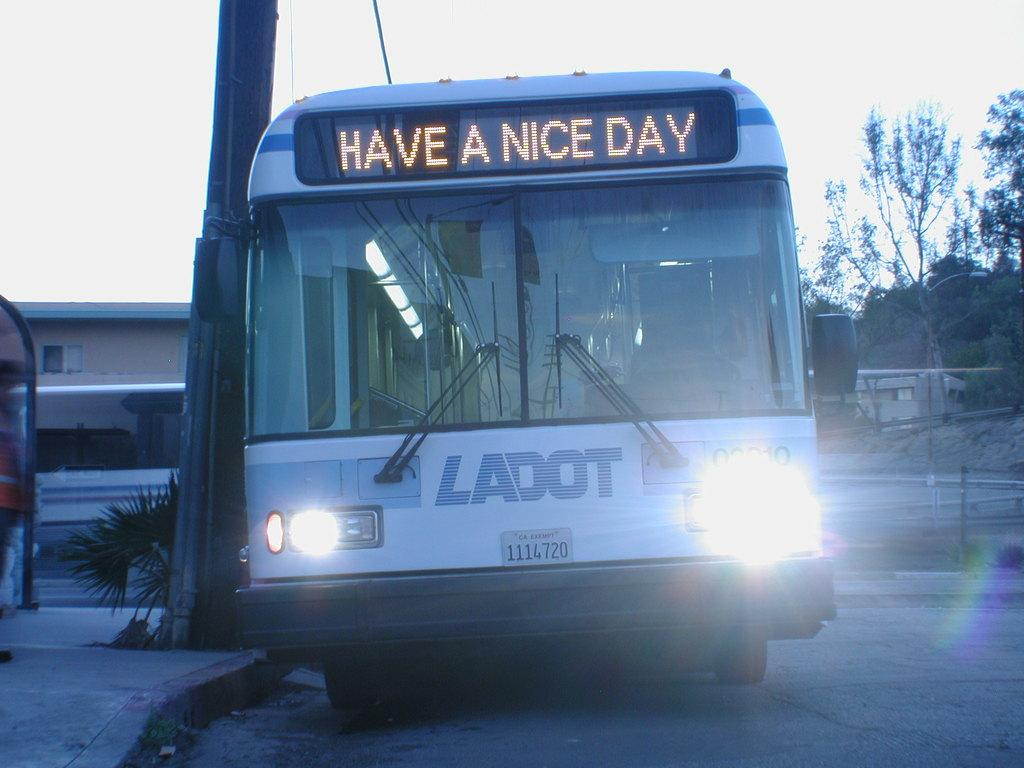<image>
Describe the image concisely. a bus that says 'have a nice day' in the front digital portion 